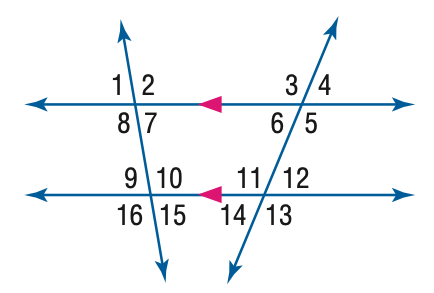Based on the image, directly select the correct answer for the following question:
Question: In the figure, m \angle 8 = 96 and m \angle 12 = 42. Find the measure of \angle 9.
Choices:
A: 42
B: 84
C: 94
D: 96 Answer:B 